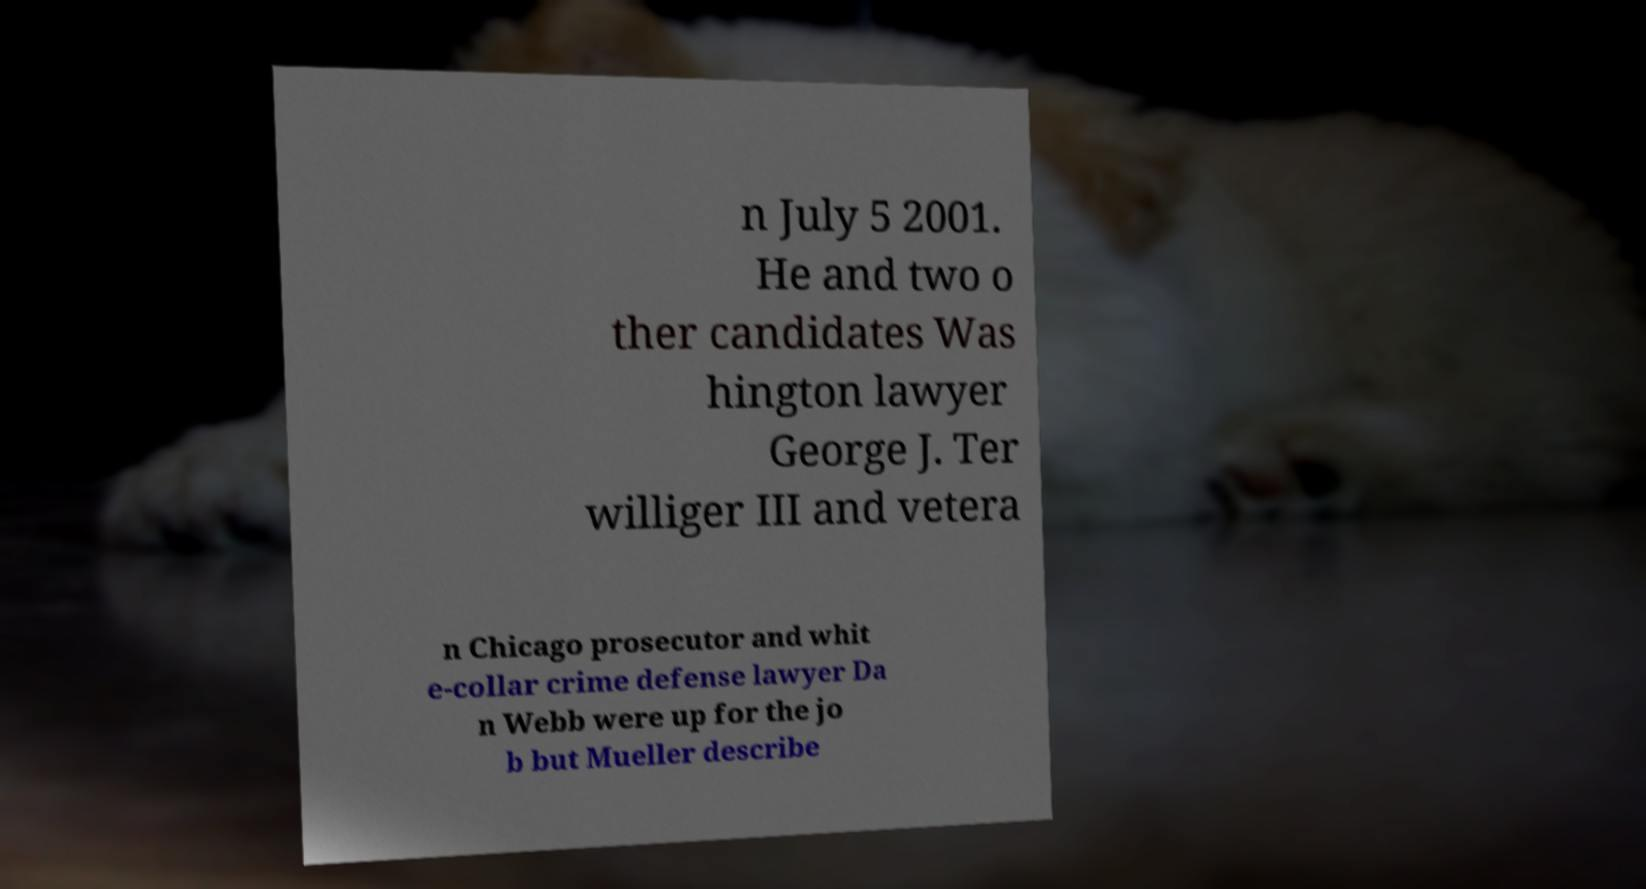Could you extract and type out the text from this image? n July 5 2001. He and two o ther candidates Was hington lawyer George J. Ter williger III and vetera n Chicago prosecutor and whit e-collar crime defense lawyer Da n Webb were up for the jo b but Mueller describe 